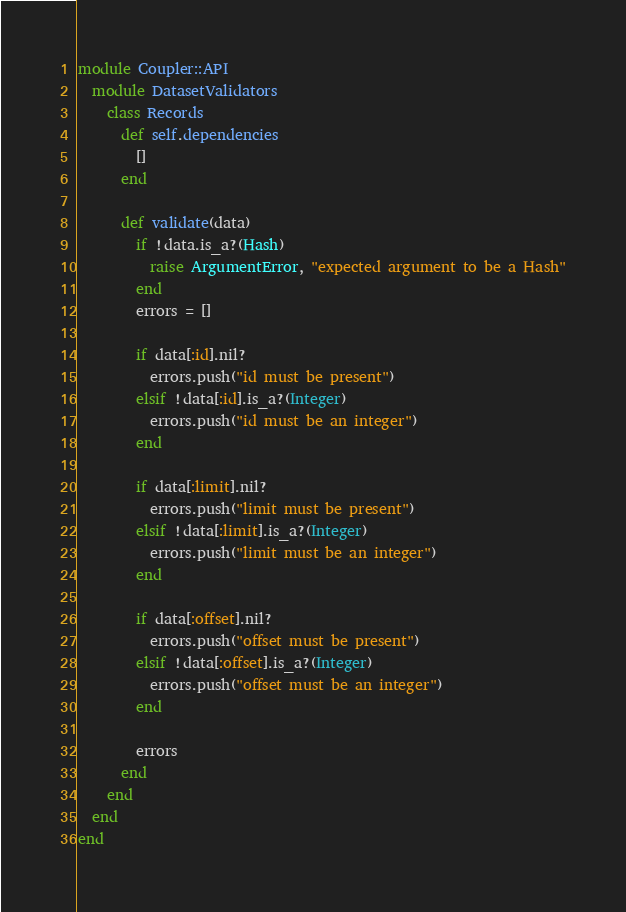Convert code to text. <code><loc_0><loc_0><loc_500><loc_500><_Ruby_>module Coupler::API
  module DatasetValidators
    class Records
      def self.dependencies
        []
      end

      def validate(data)
        if !data.is_a?(Hash)
          raise ArgumentError, "expected argument to be a Hash"
        end
        errors = []

        if data[:id].nil?
          errors.push("id must be present")
        elsif !data[:id].is_a?(Integer)
          errors.push("id must be an integer")
        end

        if data[:limit].nil?
          errors.push("limit must be present")
        elsif !data[:limit].is_a?(Integer)
          errors.push("limit must be an integer")
        end

        if data[:offset].nil?
          errors.push("offset must be present")
        elsif !data[:offset].is_a?(Integer)
          errors.push("offset must be an integer")
        end

        errors
      end
    end
  end
end
</code> 